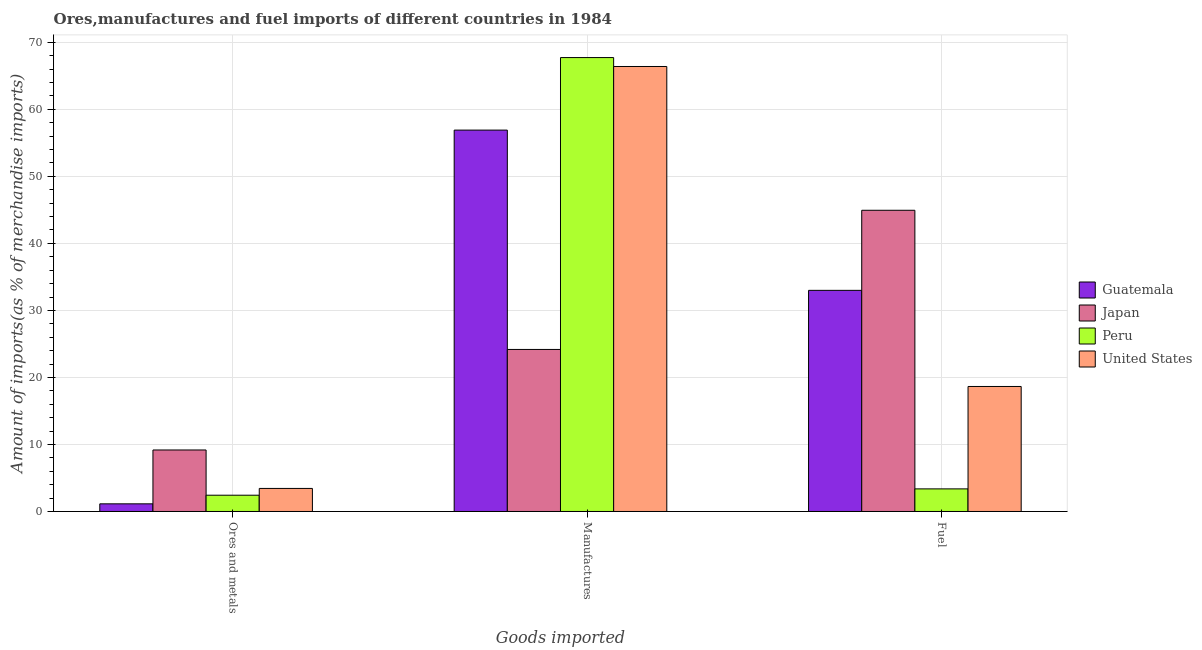How many different coloured bars are there?
Give a very brief answer. 4. How many groups of bars are there?
Provide a succinct answer. 3. How many bars are there on the 2nd tick from the left?
Keep it short and to the point. 4. How many bars are there on the 3rd tick from the right?
Give a very brief answer. 4. What is the label of the 2nd group of bars from the left?
Ensure brevity in your answer.  Manufactures. What is the percentage of manufactures imports in Guatemala?
Offer a very short reply. 56.9. Across all countries, what is the maximum percentage of ores and metals imports?
Offer a very short reply. 9.18. Across all countries, what is the minimum percentage of manufactures imports?
Ensure brevity in your answer.  24.18. In which country was the percentage of ores and metals imports minimum?
Keep it short and to the point. Guatemala. What is the total percentage of ores and metals imports in the graph?
Provide a succinct answer. 16.18. What is the difference between the percentage of manufactures imports in Guatemala and that in United States?
Give a very brief answer. -9.49. What is the difference between the percentage of ores and metals imports in Japan and the percentage of manufactures imports in Guatemala?
Your answer should be very brief. -47.73. What is the average percentage of ores and metals imports per country?
Ensure brevity in your answer.  4.05. What is the difference between the percentage of ores and metals imports and percentage of manufactures imports in Guatemala?
Make the answer very short. -55.76. In how many countries, is the percentage of fuel imports greater than 32 %?
Ensure brevity in your answer.  2. What is the ratio of the percentage of fuel imports in United States to that in Guatemala?
Keep it short and to the point. 0.57. Is the difference between the percentage of manufactures imports in Guatemala and Japan greater than the difference between the percentage of ores and metals imports in Guatemala and Japan?
Provide a succinct answer. Yes. What is the difference between the highest and the second highest percentage of manufactures imports?
Your response must be concise. 1.33. What is the difference between the highest and the lowest percentage of fuel imports?
Offer a very short reply. 41.57. In how many countries, is the percentage of manufactures imports greater than the average percentage of manufactures imports taken over all countries?
Offer a very short reply. 3. Is the sum of the percentage of ores and metals imports in Peru and Guatemala greater than the maximum percentage of manufactures imports across all countries?
Your response must be concise. No. What does the 2nd bar from the left in Manufactures represents?
Your answer should be very brief. Japan. What does the 4th bar from the right in Manufactures represents?
Keep it short and to the point. Guatemala. Is it the case that in every country, the sum of the percentage of ores and metals imports and percentage of manufactures imports is greater than the percentage of fuel imports?
Provide a succinct answer. No. How many bars are there?
Provide a short and direct response. 12. Are all the bars in the graph horizontal?
Make the answer very short. No. Where does the legend appear in the graph?
Your answer should be very brief. Center right. How are the legend labels stacked?
Your response must be concise. Vertical. What is the title of the graph?
Provide a short and direct response. Ores,manufactures and fuel imports of different countries in 1984. What is the label or title of the X-axis?
Make the answer very short. Goods imported. What is the label or title of the Y-axis?
Your answer should be compact. Amount of imports(as % of merchandise imports). What is the Amount of imports(as % of merchandise imports) of Guatemala in Ores and metals?
Offer a very short reply. 1.14. What is the Amount of imports(as % of merchandise imports) in Japan in Ores and metals?
Give a very brief answer. 9.18. What is the Amount of imports(as % of merchandise imports) in Peru in Ores and metals?
Offer a terse response. 2.43. What is the Amount of imports(as % of merchandise imports) of United States in Ores and metals?
Give a very brief answer. 3.44. What is the Amount of imports(as % of merchandise imports) of Guatemala in Manufactures?
Give a very brief answer. 56.9. What is the Amount of imports(as % of merchandise imports) in Japan in Manufactures?
Provide a succinct answer. 24.18. What is the Amount of imports(as % of merchandise imports) in Peru in Manufactures?
Offer a terse response. 67.72. What is the Amount of imports(as % of merchandise imports) in United States in Manufactures?
Make the answer very short. 66.39. What is the Amount of imports(as % of merchandise imports) of Guatemala in Fuel?
Your response must be concise. 32.99. What is the Amount of imports(as % of merchandise imports) in Japan in Fuel?
Provide a short and direct response. 44.94. What is the Amount of imports(as % of merchandise imports) in Peru in Fuel?
Keep it short and to the point. 3.37. What is the Amount of imports(as % of merchandise imports) of United States in Fuel?
Your answer should be very brief. 18.65. Across all Goods imported, what is the maximum Amount of imports(as % of merchandise imports) in Guatemala?
Your response must be concise. 56.9. Across all Goods imported, what is the maximum Amount of imports(as % of merchandise imports) in Japan?
Your answer should be compact. 44.94. Across all Goods imported, what is the maximum Amount of imports(as % of merchandise imports) of Peru?
Offer a terse response. 67.72. Across all Goods imported, what is the maximum Amount of imports(as % of merchandise imports) in United States?
Give a very brief answer. 66.39. Across all Goods imported, what is the minimum Amount of imports(as % of merchandise imports) of Guatemala?
Your response must be concise. 1.14. Across all Goods imported, what is the minimum Amount of imports(as % of merchandise imports) of Japan?
Keep it short and to the point. 9.18. Across all Goods imported, what is the minimum Amount of imports(as % of merchandise imports) of Peru?
Offer a very short reply. 2.43. Across all Goods imported, what is the minimum Amount of imports(as % of merchandise imports) in United States?
Your answer should be compact. 3.44. What is the total Amount of imports(as % of merchandise imports) in Guatemala in the graph?
Offer a terse response. 91.04. What is the total Amount of imports(as % of merchandise imports) of Japan in the graph?
Give a very brief answer. 78.3. What is the total Amount of imports(as % of merchandise imports) in Peru in the graph?
Offer a terse response. 73.53. What is the total Amount of imports(as % of merchandise imports) of United States in the graph?
Make the answer very short. 88.48. What is the difference between the Amount of imports(as % of merchandise imports) of Guatemala in Ores and metals and that in Manufactures?
Give a very brief answer. -55.76. What is the difference between the Amount of imports(as % of merchandise imports) in Peru in Ores and metals and that in Manufactures?
Your response must be concise. -65.3. What is the difference between the Amount of imports(as % of merchandise imports) of United States in Ores and metals and that in Manufactures?
Offer a very short reply. -62.95. What is the difference between the Amount of imports(as % of merchandise imports) in Guatemala in Ores and metals and that in Fuel?
Offer a terse response. -31.85. What is the difference between the Amount of imports(as % of merchandise imports) in Japan in Ores and metals and that in Fuel?
Provide a short and direct response. -35.76. What is the difference between the Amount of imports(as % of merchandise imports) in Peru in Ores and metals and that in Fuel?
Your response must be concise. -0.95. What is the difference between the Amount of imports(as % of merchandise imports) in United States in Ores and metals and that in Fuel?
Offer a very short reply. -15.21. What is the difference between the Amount of imports(as % of merchandise imports) in Guatemala in Manufactures and that in Fuel?
Keep it short and to the point. 23.91. What is the difference between the Amount of imports(as % of merchandise imports) in Japan in Manufactures and that in Fuel?
Keep it short and to the point. -20.76. What is the difference between the Amount of imports(as % of merchandise imports) of Peru in Manufactures and that in Fuel?
Your answer should be very brief. 64.35. What is the difference between the Amount of imports(as % of merchandise imports) in United States in Manufactures and that in Fuel?
Your response must be concise. 47.74. What is the difference between the Amount of imports(as % of merchandise imports) in Guatemala in Ores and metals and the Amount of imports(as % of merchandise imports) in Japan in Manufactures?
Give a very brief answer. -23.04. What is the difference between the Amount of imports(as % of merchandise imports) in Guatemala in Ores and metals and the Amount of imports(as % of merchandise imports) in Peru in Manufactures?
Offer a terse response. -66.58. What is the difference between the Amount of imports(as % of merchandise imports) in Guatemala in Ores and metals and the Amount of imports(as % of merchandise imports) in United States in Manufactures?
Give a very brief answer. -65.25. What is the difference between the Amount of imports(as % of merchandise imports) in Japan in Ores and metals and the Amount of imports(as % of merchandise imports) in Peru in Manufactures?
Your answer should be very brief. -58.55. What is the difference between the Amount of imports(as % of merchandise imports) of Japan in Ores and metals and the Amount of imports(as % of merchandise imports) of United States in Manufactures?
Keep it short and to the point. -57.22. What is the difference between the Amount of imports(as % of merchandise imports) in Peru in Ores and metals and the Amount of imports(as % of merchandise imports) in United States in Manufactures?
Offer a very short reply. -63.97. What is the difference between the Amount of imports(as % of merchandise imports) in Guatemala in Ores and metals and the Amount of imports(as % of merchandise imports) in Japan in Fuel?
Make the answer very short. -43.8. What is the difference between the Amount of imports(as % of merchandise imports) of Guatemala in Ores and metals and the Amount of imports(as % of merchandise imports) of Peru in Fuel?
Offer a terse response. -2.23. What is the difference between the Amount of imports(as % of merchandise imports) of Guatemala in Ores and metals and the Amount of imports(as % of merchandise imports) of United States in Fuel?
Keep it short and to the point. -17.51. What is the difference between the Amount of imports(as % of merchandise imports) in Japan in Ores and metals and the Amount of imports(as % of merchandise imports) in Peru in Fuel?
Provide a short and direct response. 5.8. What is the difference between the Amount of imports(as % of merchandise imports) of Japan in Ores and metals and the Amount of imports(as % of merchandise imports) of United States in Fuel?
Provide a succinct answer. -9.47. What is the difference between the Amount of imports(as % of merchandise imports) of Peru in Ores and metals and the Amount of imports(as % of merchandise imports) of United States in Fuel?
Give a very brief answer. -16.22. What is the difference between the Amount of imports(as % of merchandise imports) in Guatemala in Manufactures and the Amount of imports(as % of merchandise imports) in Japan in Fuel?
Offer a very short reply. 11.96. What is the difference between the Amount of imports(as % of merchandise imports) of Guatemala in Manufactures and the Amount of imports(as % of merchandise imports) of Peru in Fuel?
Give a very brief answer. 53.53. What is the difference between the Amount of imports(as % of merchandise imports) in Guatemala in Manufactures and the Amount of imports(as % of merchandise imports) in United States in Fuel?
Make the answer very short. 38.25. What is the difference between the Amount of imports(as % of merchandise imports) of Japan in Manufactures and the Amount of imports(as % of merchandise imports) of Peru in Fuel?
Your answer should be compact. 20.8. What is the difference between the Amount of imports(as % of merchandise imports) in Japan in Manufactures and the Amount of imports(as % of merchandise imports) in United States in Fuel?
Your answer should be very brief. 5.53. What is the difference between the Amount of imports(as % of merchandise imports) in Peru in Manufactures and the Amount of imports(as % of merchandise imports) in United States in Fuel?
Ensure brevity in your answer.  49.07. What is the average Amount of imports(as % of merchandise imports) of Guatemala per Goods imported?
Make the answer very short. 30.35. What is the average Amount of imports(as % of merchandise imports) in Japan per Goods imported?
Make the answer very short. 26.1. What is the average Amount of imports(as % of merchandise imports) in Peru per Goods imported?
Your response must be concise. 24.51. What is the average Amount of imports(as % of merchandise imports) in United States per Goods imported?
Your answer should be compact. 29.49. What is the difference between the Amount of imports(as % of merchandise imports) in Guatemala and Amount of imports(as % of merchandise imports) in Japan in Ores and metals?
Your answer should be compact. -8.04. What is the difference between the Amount of imports(as % of merchandise imports) of Guatemala and Amount of imports(as % of merchandise imports) of Peru in Ores and metals?
Keep it short and to the point. -1.29. What is the difference between the Amount of imports(as % of merchandise imports) of Guatemala and Amount of imports(as % of merchandise imports) of United States in Ores and metals?
Ensure brevity in your answer.  -2.3. What is the difference between the Amount of imports(as % of merchandise imports) of Japan and Amount of imports(as % of merchandise imports) of Peru in Ores and metals?
Provide a succinct answer. 6.75. What is the difference between the Amount of imports(as % of merchandise imports) of Japan and Amount of imports(as % of merchandise imports) of United States in Ores and metals?
Provide a short and direct response. 5.74. What is the difference between the Amount of imports(as % of merchandise imports) in Peru and Amount of imports(as % of merchandise imports) in United States in Ores and metals?
Your answer should be compact. -1.01. What is the difference between the Amount of imports(as % of merchandise imports) in Guatemala and Amount of imports(as % of merchandise imports) in Japan in Manufactures?
Provide a short and direct response. 32.73. What is the difference between the Amount of imports(as % of merchandise imports) in Guatemala and Amount of imports(as % of merchandise imports) in Peru in Manufactures?
Your answer should be compact. -10.82. What is the difference between the Amount of imports(as % of merchandise imports) in Guatemala and Amount of imports(as % of merchandise imports) in United States in Manufactures?
Your answer should be very brief. -9.49. What is the difference between the Amount of imports(as % of merchandise imports) in Japan and Amount of imports(as % of merchandise imports) in Peru in Manufactures?
Make the answer very short. -43.55. What is the difference between the Amount of imports(as % of merchandise imports) in Japan and Amount of imports(as % of merchandise imports) in United States in Manufactures?
Keep it short and to the point. -42.22. What is the difference between the Amount of imports(as % of merchandise imports) of Peru and Amount of imports(as % of merchandise imports) of United States in Manufactures?
Offer a terse response. 1.33. What is the difference between the Amount of imports(as % of merchandise imports) of Guatemala and Amount of imports(as % of merchandise imports) of Japan in Fuel?
Your response must be concise. -11.95. What is the difference between the Amount of imports(as % of merchandise imports) of Guatemala and Amount of imports(as % of merchandise imports) of Peru in Fuel?
Provide a short and direct response. 29.62. What is the difference between the Amount of imports(as % of merchandise imports) in Guatemala and Amount of imports(as % of merchandise imports) in United States in Fuel?
Your response must be concise. 14.34. What is the difference between the Amount of imports(as % of merchandise imports) of Japan and Amount of imports(as % of merchandise imports) of Peru in Fuel?
Offer a terse response. 41.57. What is the difference between the Amount of imports(as % of merchandise imports) in Japan and Amount of imports(as % of merchandise imports) in United States in Fuel?
Your response must be concise. 26.29. What is the difference between the Amount of imports(as % of merchandise imports) in Peru and Amount of imports(as % of merchandise imports) in United States in Fuel?
Offer a very short reply. -15.28. What is the ratio of the Amount of imports(as % of merchandise imports) in Guatemala in Ores and metals to that in Manufactures?
Your answer should be very brief. 0.02. What is the ratio of the Amount of imports(as % of merchandise imports) in Japan in Ores and metals to that in Manufactures?
Ensure brevity in your answer.  0.38. What is the ratio of the Amount of imports(as % of merchandise imports) in Peru in Ores and metals to that in Manufactures?
Your answer should be very brief. 0.04. What is the ratio of the Amount of imports(as % of merchandise imports) of United States in Ores and metals to that in Manufactures?
Give a very brief answer. 0.05. What is the ratio of the Amount of imports(as % of merchandise imports) in Guatemala in Ores and metals to that in Fuel?
Provide a succinct answer. 0.03. What is the ratio of the Amount of imports(as % of merchandise imports) of Japan in Ores and metals to that in Fuel?
Your answer should be compact. 0.2. What is the ratio of the Amount of imports(as % of merchandise imports) in Peru in Ores and metals to that in Fuel?
Your answer should be compact. 0.72. What is the ratio of the Amount of imports(as % of merchandise imports) of United States in Ores and metals to that in Fuel?
Your answer should be compact. 0.18. What is the ratio of the Amount of imports(as % of merchandise imports) in Guatemala in Manufactures to that in Fuel?
Offer a terse response. 1.72. What is the ratio of the Amount of imports(as % of merchandise imports) in Japan in Manufactures to that in Fuel?
Make the answer very short. 0.54. What is the ratio of the Amount of imports(as % of merchandise imports) of Peru in Manufactures to that in Fuel?
Provide a short and direct response. 20.08. What is the ratio of the Amount of imports(as % of merchandise imports) in United States in Manufactures to that in Fuel?
Make the answer very short. 3.56. What is the difference between the highest and the second highest Amount of imports(as % of merchandise imports) in Guatemala?
Your answer should be compact. 23.91. What is the difference between the highest and the second highest Amount of imports(as % of merchandise imports) of Japan?
Give a very brief answer. 20.76. What is the difference between the highest and the second highest Amount of imports(as % of merchandise imports) in Peru?
Keep it short and to the point. 64.35. What is the difference between the highest and the second highest Amount of imports(as % of merchandise imports) of United States?
Make the answer very short. 47.74. What is the difference between the highest and the lowest Amount of imports(as % of merchandise imports) in Guatemala?
Offer a very short reply. 55.76. What is the difference between the highest and the lowest Amount of imports(as % of merchandise imports) of Japan?
Ensure brevity in your answer.  35.76. What is the difference between the highest and the lowest Amount of imports(as % of merchandise imports) in Peru?
Your answer should be very brief. 65.3. What is the difference between the highest and the lowest Amount of imports(as % of merchandise imports) of United States?
Provide a short and direct response. 62.95. 